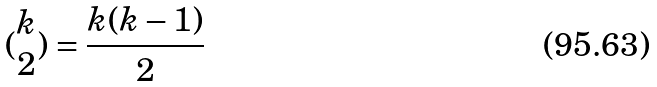<formula> <loc_0><loc_0><loc_500><loc_500>( \begin{matrix} k \\ 2 \end{matrix} ) = \frac { k ( k - 1 ) } { 2 }</formula> 